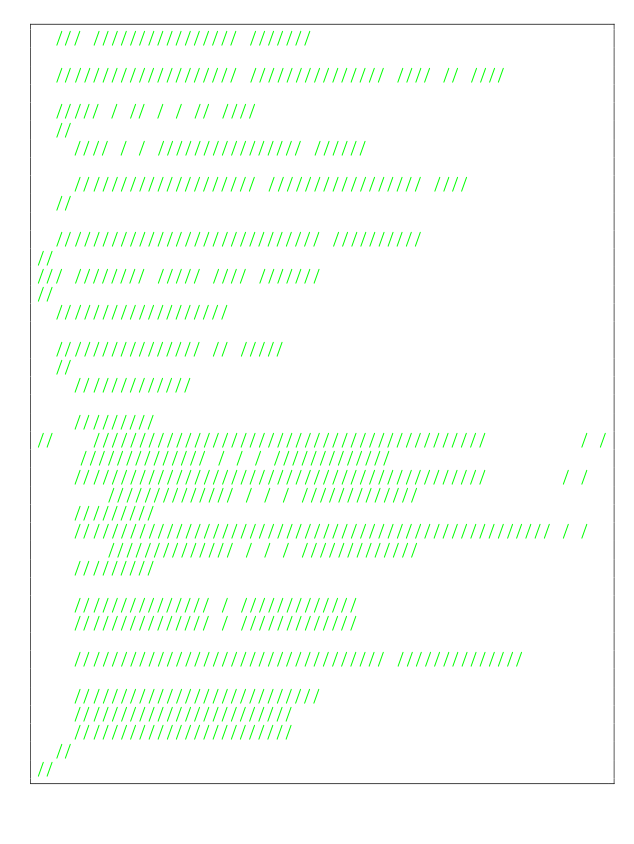Convert code to text. <code><loc_0><loc_0><loc_500><loc_500><_C_>	/// //////////////// ///////

	//////////////////// /////////////// //// // ////

	///// / // / / // ////
	//
		//// / / //////////////// //////

		//////////////////// ///////////////// ////
	//

	///////////////////////////// //////////
//
/// //////// ///// //// ///////
//
	///////////////////

	//////////////// // /////
	//
		/////////////

		/////////
//		///////////////////////////////////////////          / / ////////////// / / / /////////////
		/////////////////////////////////////////////        / / ////////////// / / / /////////////
		/////////
		//////////////////////////////////////////////////// / / ////////////// / / / /////////////
		/////////

		/////////////// / /////////////
		/////////////// / /////////////

		////////////////////////////////// //////////////

		///////////////////////////
		////////////////////////
		////////////////////////
	//
//
</code> 